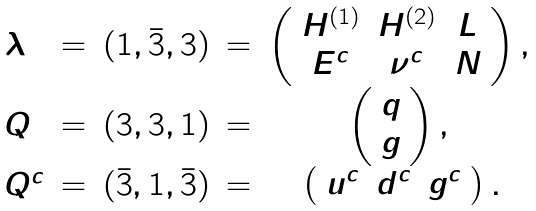Convert formula to latex. <formula><loc_0><loc_0><loc_500><loc_500>\begin{array} { l c c c c } \lambda & = & ( 1 , \bar { 3 } , 3 ) & = & \left ( \begin{array} { c c c } H ^ { ( 1 ) } & H ^ { ( 2 ) } & L \\ E ^ { c } & \nu ^ { c } & N \end{array} \right ) , \strut \\ Q & = & ( 3 , 3 , 1 ) & = & \left ( \begin{array} { c } q \\ g \end{array} \right ) , \strut \\ Q ^ { c } & = & ( \bar { 3 } , 1 , \bar { 3 } ) & = & \left ( \begin{array} { c c c } u ^ { c } & d ^ { c } & g ^ { c } \end{array} \right ) . \end{array}</formula> 